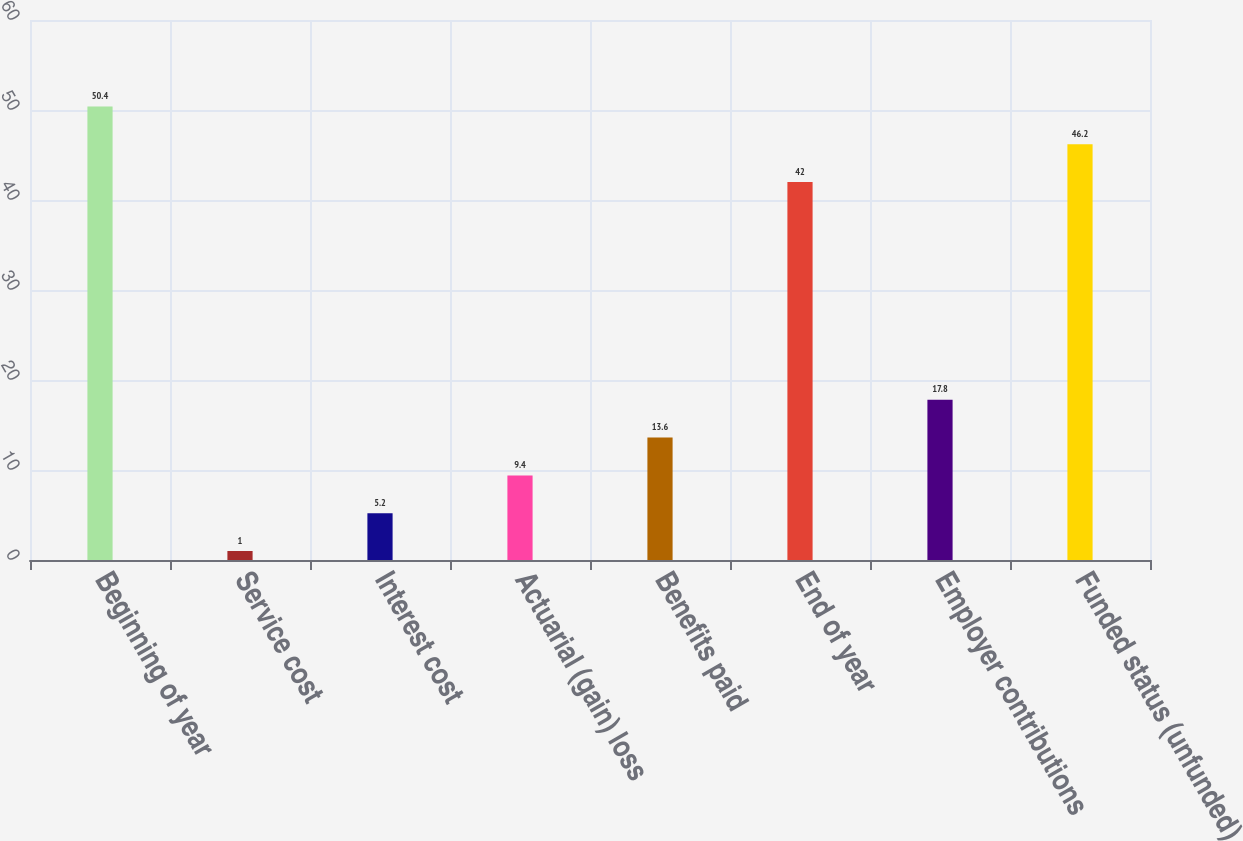Convert chart to OTSL. <chart><loc_0><loc_0><loc_500><loc_500><bar_chart><fcel>Beginning of year<fcel>Service cost<fcel>Interest cost<fcel>Actuarial (gain) loss<fcel>Benefits paid<fcel>End of year<fcel>Employer contributions<fcel>Funded status (unfunded)<nl><fcel>50.4<fcel>1<fcel>5.2<fcel>9.4<fcel>13.6<fcel>42<fcel>17.8<fcel>46.2<nl></chart> 